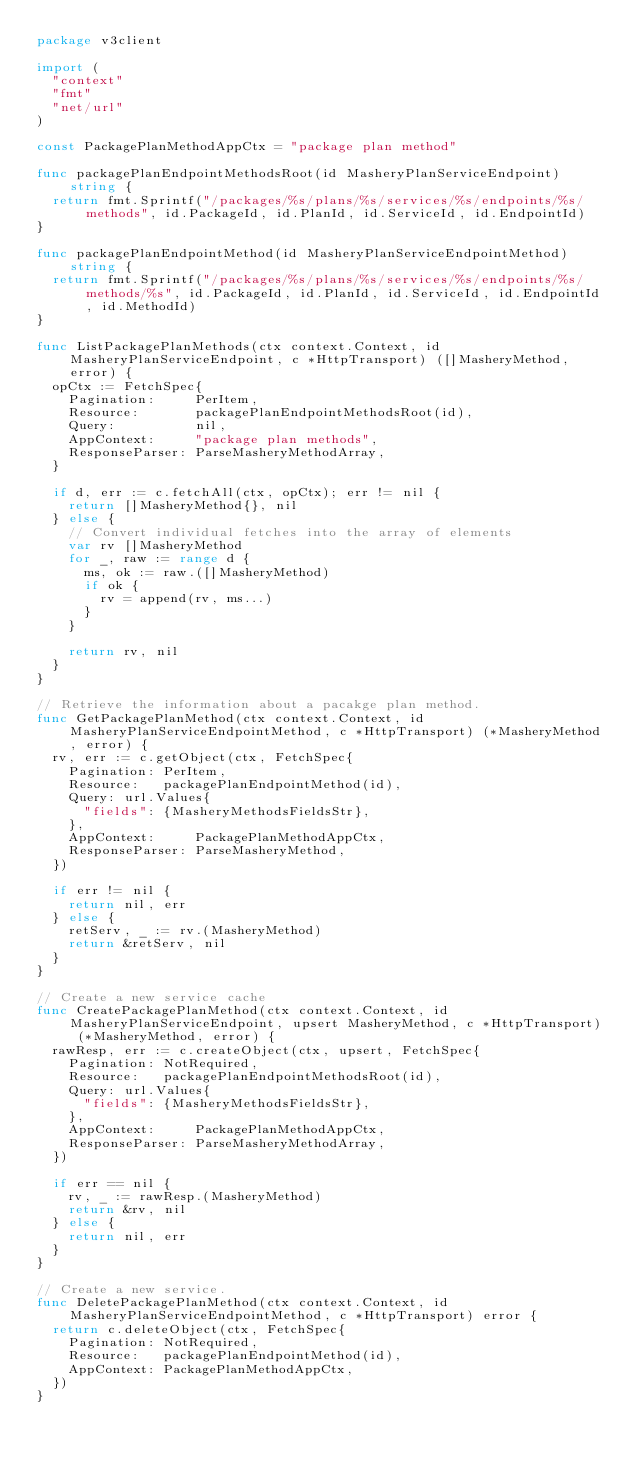Convert code to text. <code><loc_0><loc_0><loc_500><loc_500><_Go_>package v3client

import (
	"context"
	"fmt"
	"net/url"
)

const PackagePlanMethodAppCtx = "package plan method"

func packagePlanEndpointMethodsRoot(id MasheryPlanServiceEndpoint) string {
	return fmt.Sprintf("/packages/%s/plans/%s/services/%s/endpoints/%s/methods", id.PackageId, id.PlanId, id.ServiceId, id.EndpointId)
}

func packagePlanEndpointMethod(id MasheryPlanServiceEndpointMethod) string {
	return fmt.Sprintf("/packages/%s/plans/%s/services/%s/endpoints/%s/methods/%s", id.PackageId, id.PlanId, id.ServiceId, id.EndpointId, id.MethodId)
}

func ListPackagePlanMethods(ctx context.Context, id MasheryPlanServiceEndpoint, c *HttpTransport) ([]MasheryMethod, error) {
	opCtx := FetchSpec{
		Pagination:     PerItem,
		Resource:       packagePlanEndpointMethodsRoot(id),
		Query:          nil,
		AppContext:     "package plan methods",
		ResponseParser: ParseMasheryMethodArray,
	}

	if d, err := c.fetchAll(ctx, opCtx); err != nil {
		return []MasheryMethod{}, nil
	} else {
		// Convert individual fetches into the array of elements
		var rv []MasheryMethod
		for _, raw := range d {
			ms, ok := raw.([]MasheryMethod)
			if ok {
				rv = append(rv, ms...)
			}
		}

		return rv, nil
	}
}

// Retrieve the information about a pacakge plan method.
func GetPackagePlanMethod(ctx context.Context, id MasheryPlanServiceEndpointMethod, c *HttpTransport) (*MasheryMethod, error) {
	rv, err := c.getObject(ctx, FetchSpec{
		Pagination: PerItem,
		Resource:   packagePlanEndpointMethod(id),
		Query: url.Values{
			"fields": {MasheryMethodsFieldsStr},
		},
		AppContext:     PackagePlanMethodAppCtx,
		ResponseParser: ParseMasheryMethod,
	})

	if err != nil {
		return nil, err
	} else {
		retServ, _ := rv.(MasheryMethod)
		return &retServ, nil
	}
}

// Create a new service cache
func CreatePackagePlanMethod(ctx context.Context, id MasheryPlanServiceEndpoint, upsert MasheryMethod, c *HttpTransport) (*MasheryMethod, error) {
	rawResp, err := c.createObject(ctx, upsert, FetchSpec{
		Pagination: NotRequired,
		Resource:   packagePlanEndpointMethodsRoot(id),
		Query: url.Values{
			"fields": {MasheryMethodsFieldsStr},
		},
		AppContext:     PackagePlanMethodAppCtx,
		ResponseParser: ParseMasheryMethodArray,
	})

	if err == nil {
		rv, _ := rawResp.(MasheryMethod)
		return &rv, nil
	} else {
		return nil, err
	}
}

// Create a new service.
func DeletePackagePlanMethod(ctx context.Context, id MasheryPlanServiceEndpointMethod, c *HttpTransport) error {
	return c.deleteObject(ctx, FetchSpec{
		Pagination: NotRequired,
		Resource:   packagePlanEndpointMethod(id),
		AppContext: PackagePlanMethodAppCtx,
	})
}
</code> 